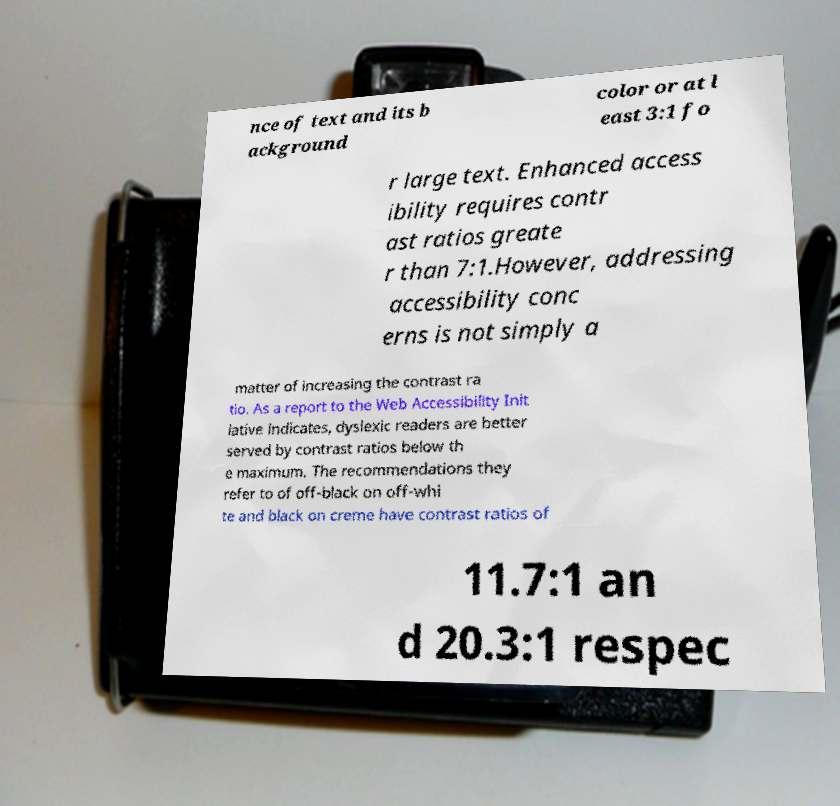Could you extract and type out the text from this image? nce of text and its b ackground color or at l east 3:1 fo r large text. Enhanced access ibility requires contr ast ratios greate r than 7:1.However, addressing accessibility conc erns is not simply a matter of increasing the contrast ra tio. As a report to the Web Accessibility Init iative indicates, dyslexic readers are better served by contrast ratios below th e maximum. The recommendations they refer to of off-black on off-whi te and black on creme have contrast ratios of 11.7:1 an d 20.3:1 respec 